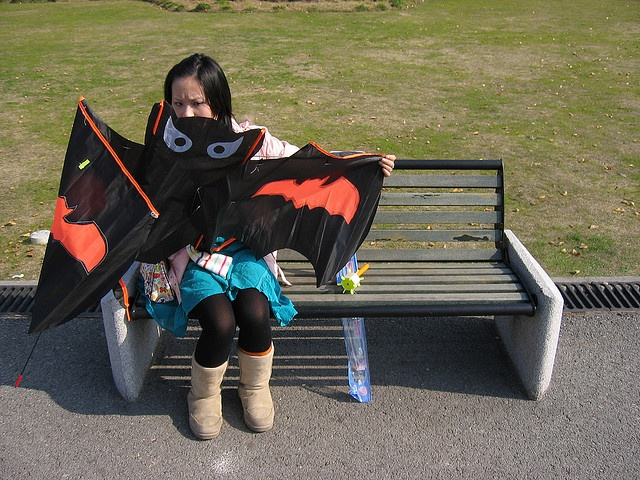Describe the objects in this image and their specific colors. I can see people in darkgreen, black, gray, salmon, and white tones, kite in darkgreen, black, salmon, gray, and maroon tones, bench in darkgreen, gray, black, and darkgray tones, and handbag in darkgreen, gray, black, and darkgray tones in this image. 